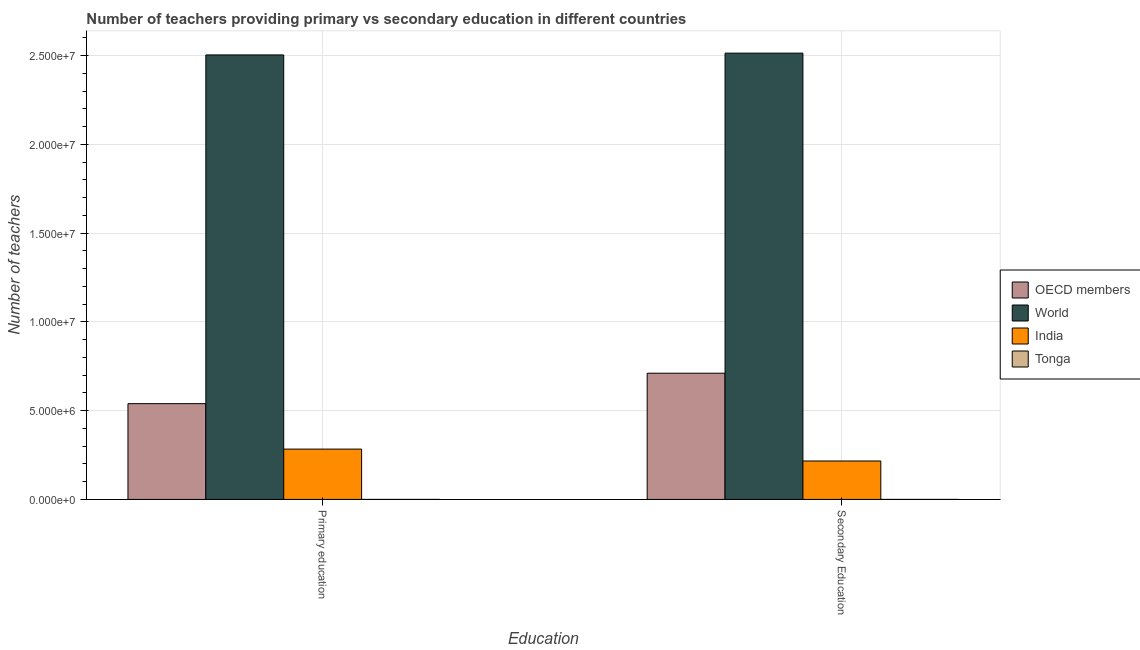How many different coloured bars are there?
Provide a succinct answer. 4. Are the number of bars per tick equal to the number of legend labels?
Keep it short and to the point. Yes. What is the number of secondary teachers in World?
Your answer should be compact. 2.51e+07. Across all countries, what is the maximum number of secondary teachers?
Your answer should be compact. 2.51e+07. Across all countries, what is the minimum number of secondary teachers?
Your answer should be very brief. 1021. In which country was the number of primary teachers maximum?
Offer a very short reply. World. In which country was the number of secondary teachers minimum?
Provide a short and direct response. Tonga. What is the total number of primary teachers in the graph?
Provide a succinct answer. 3.33e+07. What is the difference between the number of primary teachers in OECD members and that in India?
Your answer should be compact. 2.56e+06. What is the difference between the number of primary teachers in India and the number of secondary teachers in World?
Give a very brief answer. -2.23e+07. What is the average number of secondary teachers per country?
Provide a short and direct response. 8.60e+06. What is the difference between the number of secondary teachers and number of primary teachers in Tonga?
Offer a very short reply. 198. What is the ratio of the number of primary teachers in India to that in World?
Offer a terse response. 0.11. Is the number of secondary teachers in World less than that in India?
Ensure brevity in your answer.  No. Are the values on the major ticks of Y-axis written in scientific E-notation?
Offer a terse response. Yes. Does the graph contain any zero values?
Your response must be concise. No. Does the graph contain grids?
Offer a very short reply. Yes. Where does the legend appear in the graph?
Keep it short and to the point. Center right. How many legend labels are there?
Your answer should be very brief. 4. How are the legend labels stacked?
Your answer should be compact. Vertical. What is the title of the graph?
Provide a succinct answer. Number of teachers providing primary vs secondary education in different countries. Does "Malta" appear as one of the legend labels in the graph?
Provide a succinct answer. No. What is the label or title of the X-axis?
Your answer should be very brief. Education. What is the label or title of the Y-axis?
Offer a very short reply. Number of teachers. What is the Number of teachers of OECD members in Primary education?
Offer a very short reply. 5.40e+06. What is the Number of teachers of World in Primary education?
Keep it short and to the point. 2.50e+07. What is the Number of teachers of India in Primary education?
Ensure brevity in your answer.  2.84e+06. What is the Number of teachers of Tonga in Primary education?
Offer a terse response. 823. What is the Number of teachers of OECD members in Secondary Education?
Provide a succinct answer. 7.11e+06. What is the Number of teachers in World in Secondary Education?
Make the answer very short. 2.51e+07. What is the Number of teachers in India in Secondary Education?
Offer a terse response. 2.16e+06. What is the Number of teachers in Tonga in Secondary Education?
Offer a terse response. 1021. Across all Education, what is the maximum Number of teachers of OECD members?
Keep it short and to the point. 7.11e+06. Across all Education, what is the maximum Number of teachers in World?
Ensure brevity in your answer.  2.51e+07. Across all Education, what is the maximum Number of teachers in India?
Your response must be concise. 2.84e+06. Across all Education, what is the maximum Number of teachers of Tonga?
Ensure brevity in your answer.  1021. Across all Education, what is the minimum Number of teachers in OECD members?
Your response must be concise. 5.40e+06. Across all Education, what is the minimum Number of teachers of World?
Your answer should be compact. 2.50e+07. Across all Education, what is the minimum Number of teachers in India?
Give a very brief answer. 2.16e+06. Across all Education, what is the minimum Number of teachers in Tonga?
Your answer should be compact. 823. What is the total Number of teachers of OECD members in the graph?
Offer a terse response. 1.25e+07. What is the total Number of teachers of World in the graph?
Keep it short and to the point. 5.02e+07. What is the total Number of teachers of India in the graph?
Make the answer very short. 5.00e+06. What is the total Number of teachers in Tonga in the graph?
Offer a terse response. 1844. What is the difference between the Number of teachers of OECD members in Primary education and that in Secondary Education?
Keep it short and to the point. -1.71e+06. What is the difference between the Number of teachers of World in Primary education and that in Secondary Education?
Offer a very short reply. -1.01e+05. What is the difference between the Number of teachers of India in Primary education and that in Secondary Education?
Offer a very short reply. 6.70e+05. What is the difference between the Number of teachers in Tonga in Primary education and that in Secondary Education?
Your answer should be compact. -198. What is the difference between the Number of teachers of OECD members in Primary education and the Number of teachers of World in Secondary Education?
Keep it short and to the point. -1.97e+07. What is the difference between the Number of teachers of OECD members in Primary education and the Number of teachers of India in Secondary Education?
Your answer should be very brief. 3.23e+06. What is the difference between the Number of teachers of OECD members in Primary education and the Number of teachers of Tonga in Secondary Education?
Offer a terse response. 5.39e+06. What is the difference between the Number of teachers of World in Primary education and the Number of teachers of India in Secondary Education?
Ensure brevity in your answer.  2.29e+07. What is the difference between the Number of teachers in World in Primary education and the Number of teachers in Tonga in Secondary Education?
Provide a succinct answer. 2.50e+07. What is the difference between the Number of teachers of India in Primary education and the Number of teachers of Tonga in Secondary Education?
Provide a short and direct response. 2.83e+06. What is the average Number of teachers of OECD members per Education?
Keep it short and to the point. 6.25e+06. What is the average Number of teachers in World per Education?
Keep it short and to the point. 2.51e+07. What is the average Number of teachers of India per Education?
Offer a very short reply. 2.50e+06. What is the average Number of teachers of Tonga per Education?
Provide a short and direct response. 922. What is the difference between the Number of teachers in OECD members and Number of teachers in World in Primary education?
Make the answer very short. -1.96e+07. What is the difference between the Number of teachers of OECD members and Number of teachers of India in Primary education?
Provide a short and direct response. 2.56e+06. What is the difference between the Number of teachers in OECD members and Number of teachers in Tonga in Primary education?
Keep it short and to the point. 5.39e+06. What is the difference between the Number of teachers in World and Number of teachers in India in Primary education?
Offer a terse response. 2.22e+07. What is the difference between the Number of teachers of World and Number of teachers of Tonga in Primary education?
Keep it short and to the point. 2.50e+07. What is the difference between the Number of teachers of India and Number of teachers of Tonga in Primary education?
Provide a short and direct response. 2.83e+06. What is the difference between the Number of teachers in OECD members and Number of teachers in World in Secondary Education?
Ensure brevity in your answer.  -1.80e+07. What is the difference between the Number of teachers in OECD members and Number of teachers in India in Secondary Education?
Keep it short and to the point. 4.94e+06. What is the difference between the Number of teachers of OECD members and Number of teachers of Tonga in Secondary Education?
Keep it short and to the point. 7.11e+06. What is the difference between the Number of teachers of World and Number of teachers of India in Secondary Education?
Offer a terse response. 2.30e+07. What is the difference between the Number of teachers of World and Number of teachers of Tonga in Secondary Education?
Your response must be concise. 2.51e+07. What is the difference between the Number of teachers in India and Number of teachers in Tonga in Secondary Education?
Make the answer very short. 2.16e+06. What is the ratio of the Number of teachers in OECD members in Primary education to that in Secondary Education?
Keep it short and to the point. 0.76. What is the ratio of the Number of teachers of India in Primary education to that in Secondary Education?
Ensure brevity in your answer.  1.31. What is the ratio of the Number of teachers in Tonga in Primary education to that in Secondary Education?
Give a very brief answer. 0.81. What is the difference between the highest and the second highest Number of teachers of OECD members?
Keep it short and to the point. 1.71e+06. What is the difference between the highest and the second highest Number of teachers in World?
Your response must be concise. 1.01e+05. What is the difference between the highest and the second highest Number of teachers of India?
Your response must be concise. 6.70e+05. What is the difference between the highest and the second highest Number of teachers of Tonga?
Offer a very short reply. 198. What is the difference between the highest and the lowest Number of teachers of OECD members?
Your answer should be compact. 1.71e+06. What is the difference between the highest and the lowest Number of teachers in World?
Your response must be concise. 1.01e+05. What is the difference between the highest and the lowest Number of teachers in India?
Your response must be concise. 6.70e+05. What is the difference between the highest and the lowest Number of teachers of Tonga?
Make the answer very short. 198. 